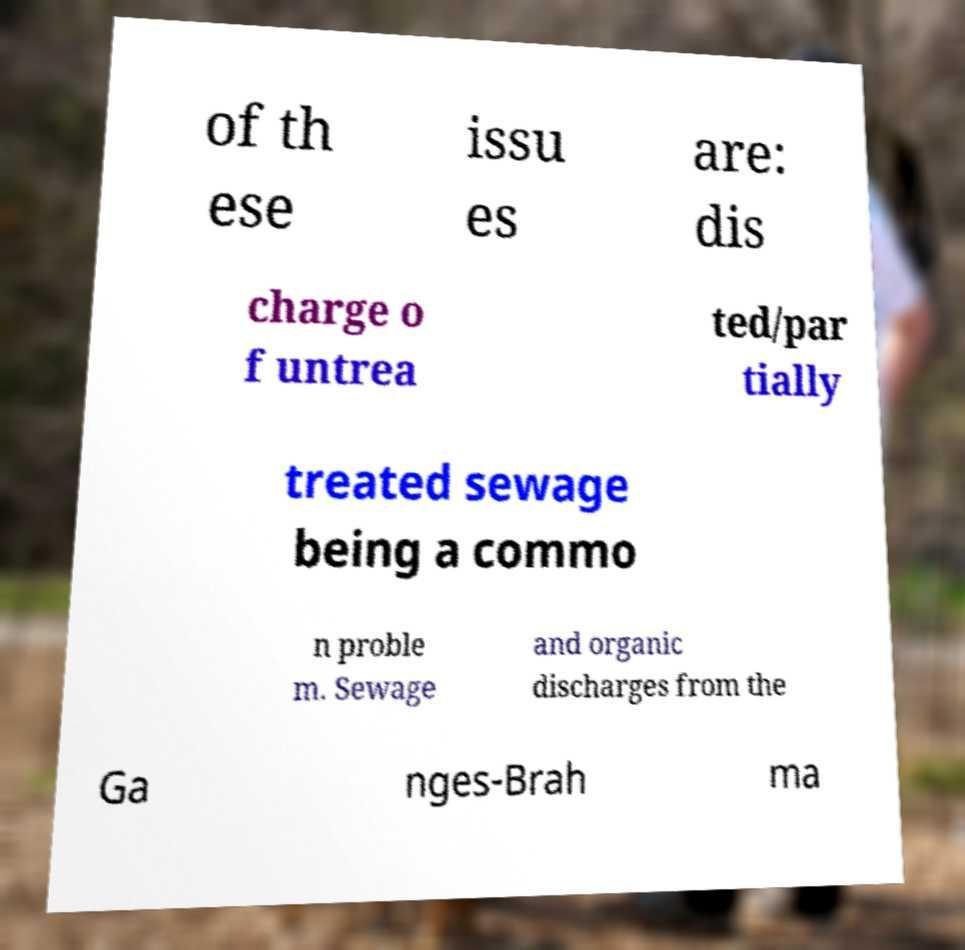Could you assist in decoding the text presented in this image and type it out clearly? of th ese issu es are: dis charge o f untrea ted/par tially treated sewage being a commo n proble m. Sewage and organic discharges from the Ga nges-Brah ma 